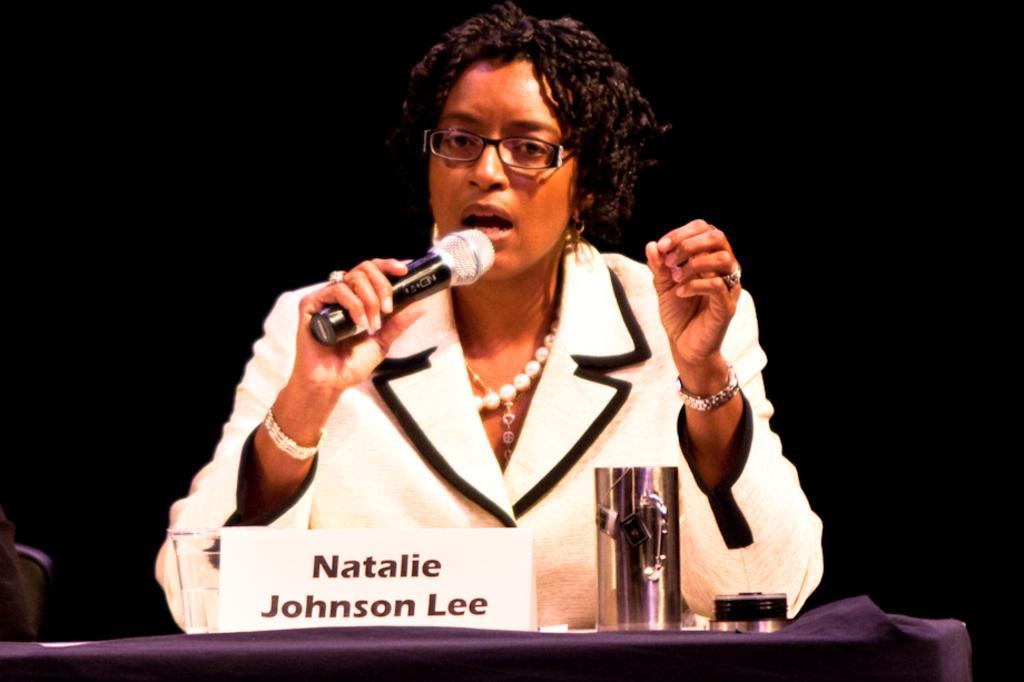In one or two sentences, can you explain what this image depicts? There is a woman who is talking on the mike. She has spectacles. This is table. On the table there is a glass. 